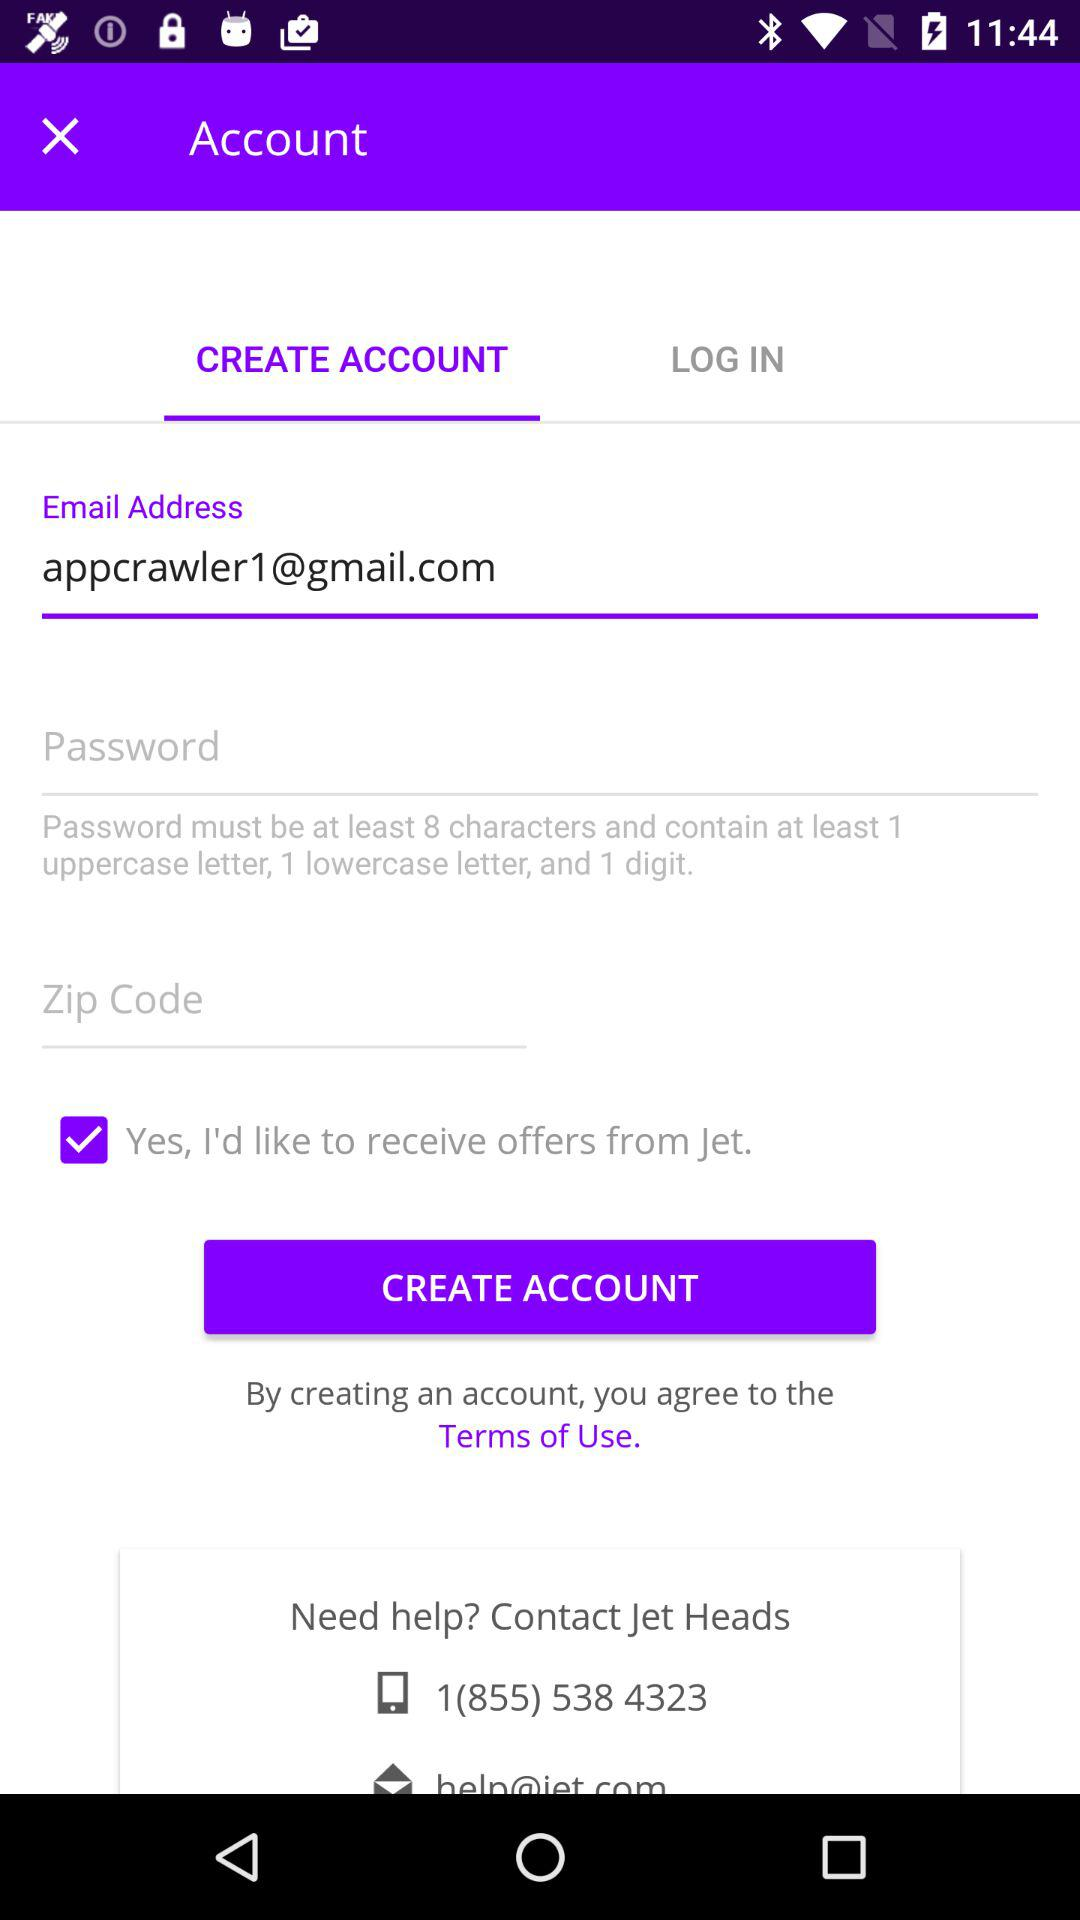How many input fields require the user to enter information?
Answer the question using a single word or phrase. 3 